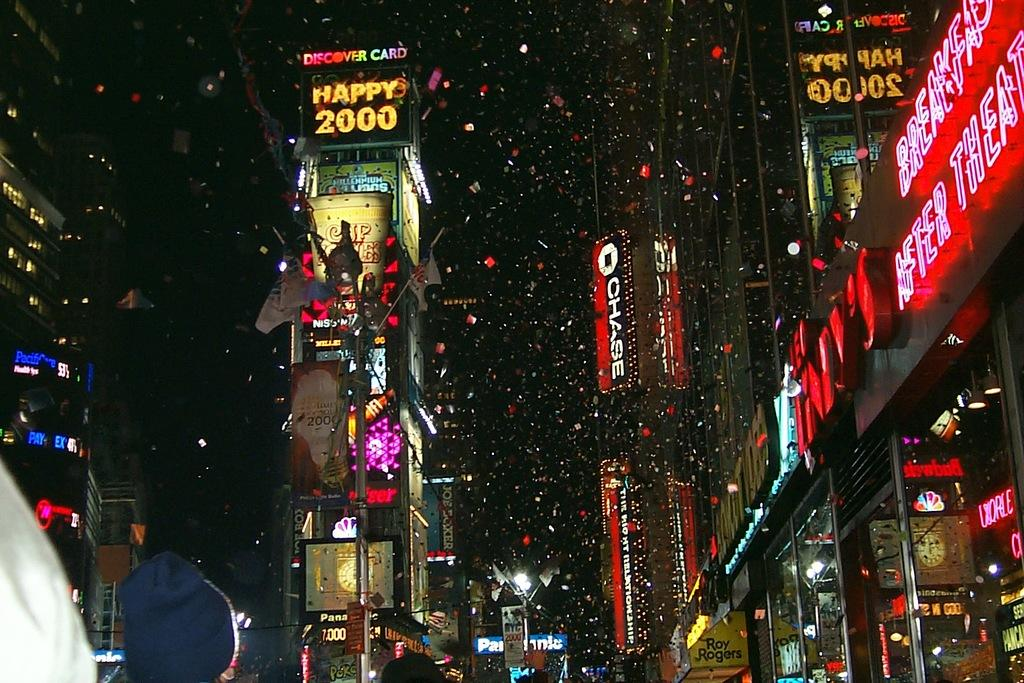What type of structures can be seen in the image? There are buildings in the image. What is attached to the poles in the image? Flags with poles can be seen in the image. What are the poles used for in the image? The poles are used to hold flags and lights in the image. What type of illumination is present in the image? There are lights in the image. What type of signage is present in the image? There are boards in the image. What is the color of the background in the image? The background of the image is dark. What type of meat is being grilled on the barbecue in the image? There is no barbecue or meat present in the image. What type of leather is being used to make the baby's shoes in the image? There are no babies or shoes present in the image. 